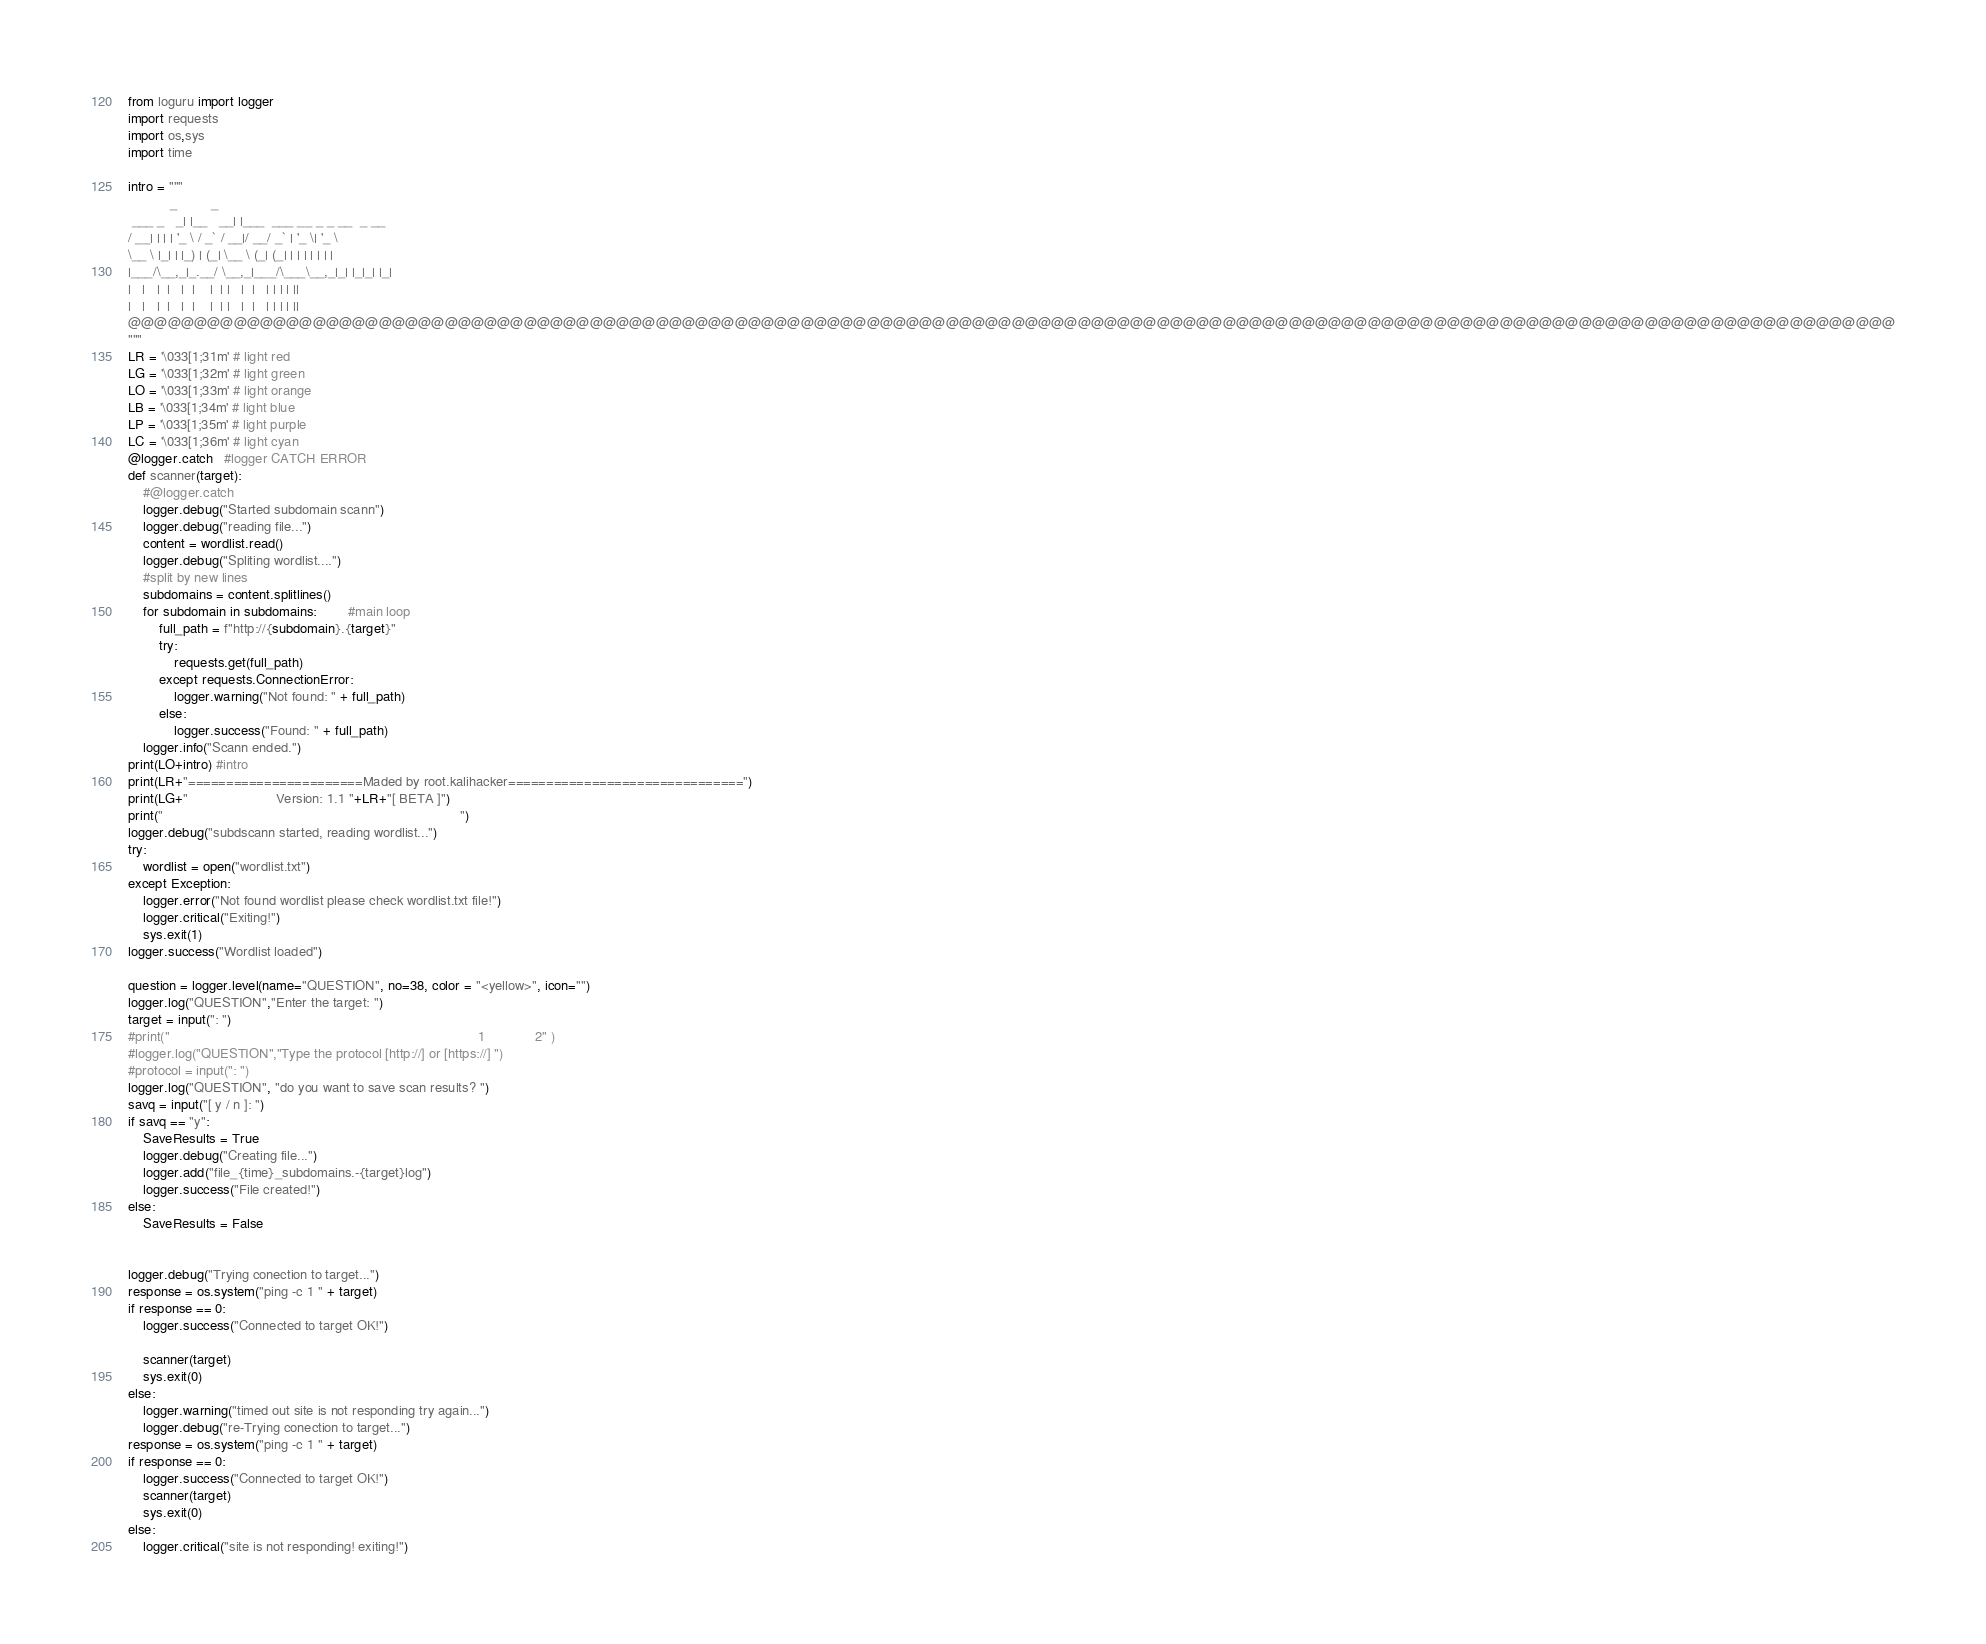<code> <loc_0><loc_0><loc_500><loc_500><_Python_>from loguru import logger
import requests
import os,sys
import time

intro = """
           _         _                           
 ___ _   _| |__   __| |___  ___ __ _ _ __  _ __  
/ __| | | | '_ \ / _` / __|/ __/ _` | '_ \| '_ \ 
\__ \ |_| | |_) | (_| \__ \ (_| (_| | | | | | | |
|___/\__,_|_.__/ \__,_|___/\___\__,_|_| |_|_| |_|
|   |   |  |   |  |    |  | |   |  |   | | | | ||                 
|   |   |  |   |  |    |  | |   |  |   | | | | ||                     
@@@@@@@@@@@@@@@@@@@@@@@@@@@@@@@@@@@@@@@@@@@@@@@@@@@@@@@@@@@@@@@@@@@@@@@@@@@@@@@@@@@@@@@@@@@@@@@@@@@@@@@@@@@@@@@@@@@@@@@@@@@@@@@@@@@@@@
""" 
LR = '\033[1;31m' # light red
LG = '\033[1;32m' # light green
LO = '\033[1;33m' # light orange
LB = '\033[1;34m' # light blue
LP = '\033[1;35m' # light purple
LC = '\033[1;36m' # light cyan
@logger.catch   #logger CATCH ERROR 
def scanner(target): 
    #@logger.catch
    logger.debug("Started subdomain scann")
    logger.debug("reading file...")
    content = wordlist.read()
    logger.debug("Spliting wordlist....")
    #split by new lines
    subdomains = content.splitlines()
    for subdomain in subdomains:        #main loop
        full_path = f"http://{subdomain}.{target}"
        try:
            requests.get(full_path)
        except requests.ConnectionError:
            logger.warning("Not found: " + full_path)
        else:
            logger.success("Found: " + full_path)
    logger.info("Scann ended.")
print(LO+intro) #intro
print(LR+"=======================Maded by root.kalihacker===============================")
print(LG+"                       Version: 1.1 "+LR+"[ BETA ]")
print("                                                                              ")
logger.debug("subdscann started, reading wordlist...")
try:
    wordlist = open("wordlist.txt")
except Exception:
    logger.error("Not found wordlist please check wordlist.txt file!")
    logger.critical("Exiting!")
    sys.exit(1)
logger.success("Wordlist loaded")

question = logger.level(name="QUESTION", no=38, color = "<yellow>", icon="")
logger.log("QUESTION","Enter the target: ")
target = input(": ")
#print("                                                                                 1             2" )
#logger.log("QUESTION","Type the protocol [http://] or [https://] ")
#protocol = input(": ")
logger.log("QUESTION", "do you want to save scan results? ")
savq = input("[ y / n ]: ")
if savq == "y":
    SaveResults = True
    logger.debug("Creating file...")
    logger.add("file_{time}_subdomains.-{target}log")
    logger.success("File created!")
else:
    SaveResults = False


logger.debug("Trying conection to target...")
response = os.system("ping -c 1 " + target)
if response == 0:
    logger.success("Connected to target OK!")

    scanner(target)
    sys.exit(0)
else:
    logger.warning("timed out site is not responding try again...")
    logger.debug("re-Trying conection to target...")
response = os.system("ping -c 1 " + target)
if response == 0:
    logger.success("Connected to target OK!")
    scanner(target)
    sys.exit(0)
else:
    logger.critical("site is not responding! exiting!")
</code> 